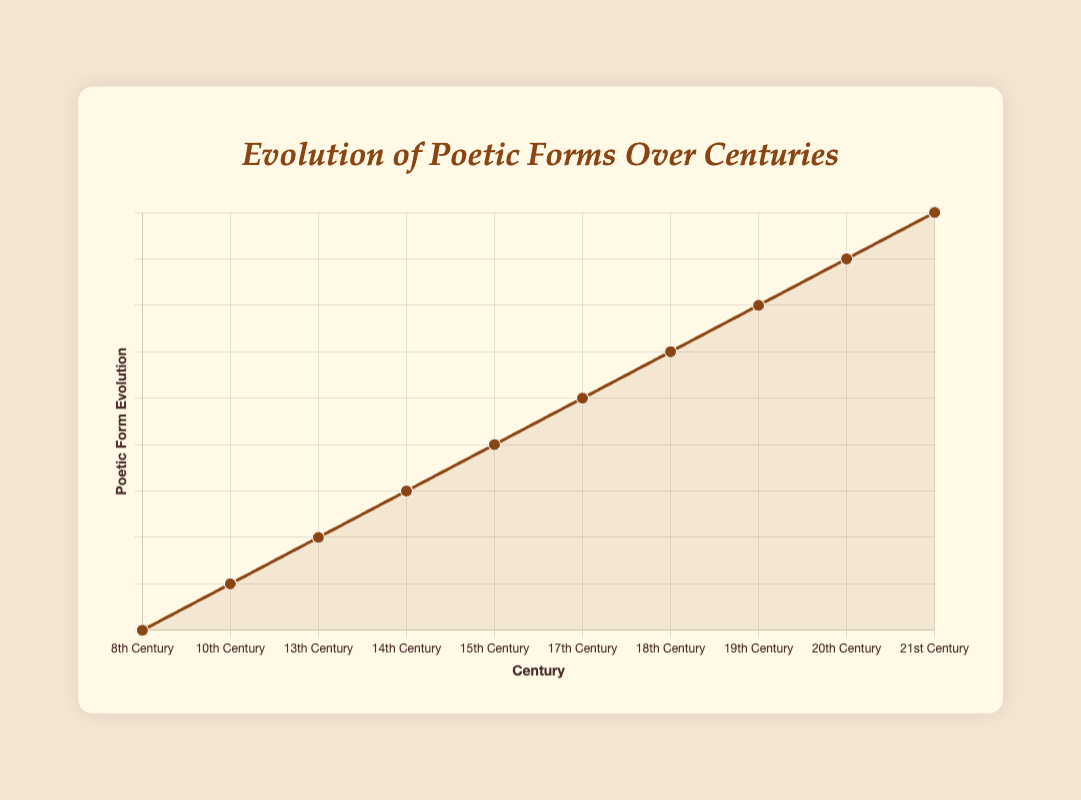What's the earliest century depicted in the graph for the introduction of a poetic form? We start by identifying the poetic form introduced in the earliest century visible in the chart. The sequence of centuries indicates that the earliest century is the 8th. On examining this data point, it shows that the "Tanka" poem from Japanese culture is first introduced.
Answer: 8th century Which century marks the introduction of the Sonnet in the graph? By observing the plotted centuries, we look for the century that corresponds with the label "Sonnet." It becomes clear when we see that the Sonnet was introduced in the 13th century, with notable poets like Dante Alighieri and Petrarch.
Answer: 13th century How many centuries did pass between the introduction of the Ballad and Free Verse? To determine the difference between the centuries when the Ballad and Free Verse were introduced, we compare the labeled data for each form. The Ballad was introduced in the 14th century and the Free Verse in the 19th century. Calculating the difference: 19th - 14th = 5 centuries.
Answer: 5 centuries Between the Persian Ghazal and Chinese Ci, which was introduced earlier and by how many centuries? First, by locating the Ghazal and Ci on the graph, we see that the Ghazal appeared in the 10th century and the Ci in the 15th century. Subtracting the 10th century from the 15th century gives the difference: 15 - 10 = 5 centuries, indicating the Ghazal was introduced 5 centuries earlier.
Answer: Ghazal, 5 centuries What is the average century for the introduction of the Italian Sonnet, French Alexandrine, and American Free Verse? Locate each form on the century timeline: Sonnet in the 13th century, Alexandrine in the 17th century, and Free Verse in the 19th century. Calculate the average of these centuries: (13 + 17 + 19) / 3 = 49 / 3 = 16.33, approximately the 17th century.
Answer: 17th century Which poetic form was introduced most recently according to the chart, and in which century? By analyzing the chronological plot, we identify the 21st century as the most recent. The poetic form tagged to this century is "Spoken Word" from a global culture.
Answer: Spoken Word, 21st century Visually, which two data points are the furthest apart in terms of centuries on the chart? Consider the range of points from the earliest and latest centuries: the 8th century (Tanka) to the 21st century (Spoken Word). The difference between these is substantial: 21st - 8th = 13 centuries apart.
Answer: Tanka and Spoken Word, 13 centuries Compare the notable poets of Ghazal and Bhakti Poetry. How many poets are listed for each form? Examine the tooltip or text for these forms: Ghazal has Rudaki and Ferdowsi, totaling 2 poets. Bhakti Poetry includes Mirabai and Kabir, also tallying to 2 poets.
Answer: Both have 2 poets What's the common feature for all the poetic forms alongside their respective cultures shown on the plot? By referring to each culture's attributes and poetic forms, we recognize that each culture highlights its distinctive poetic form that evolved: from the Japanese Tanka to the Russian Acmeism.
Answer: Unique poetic form from each culture 